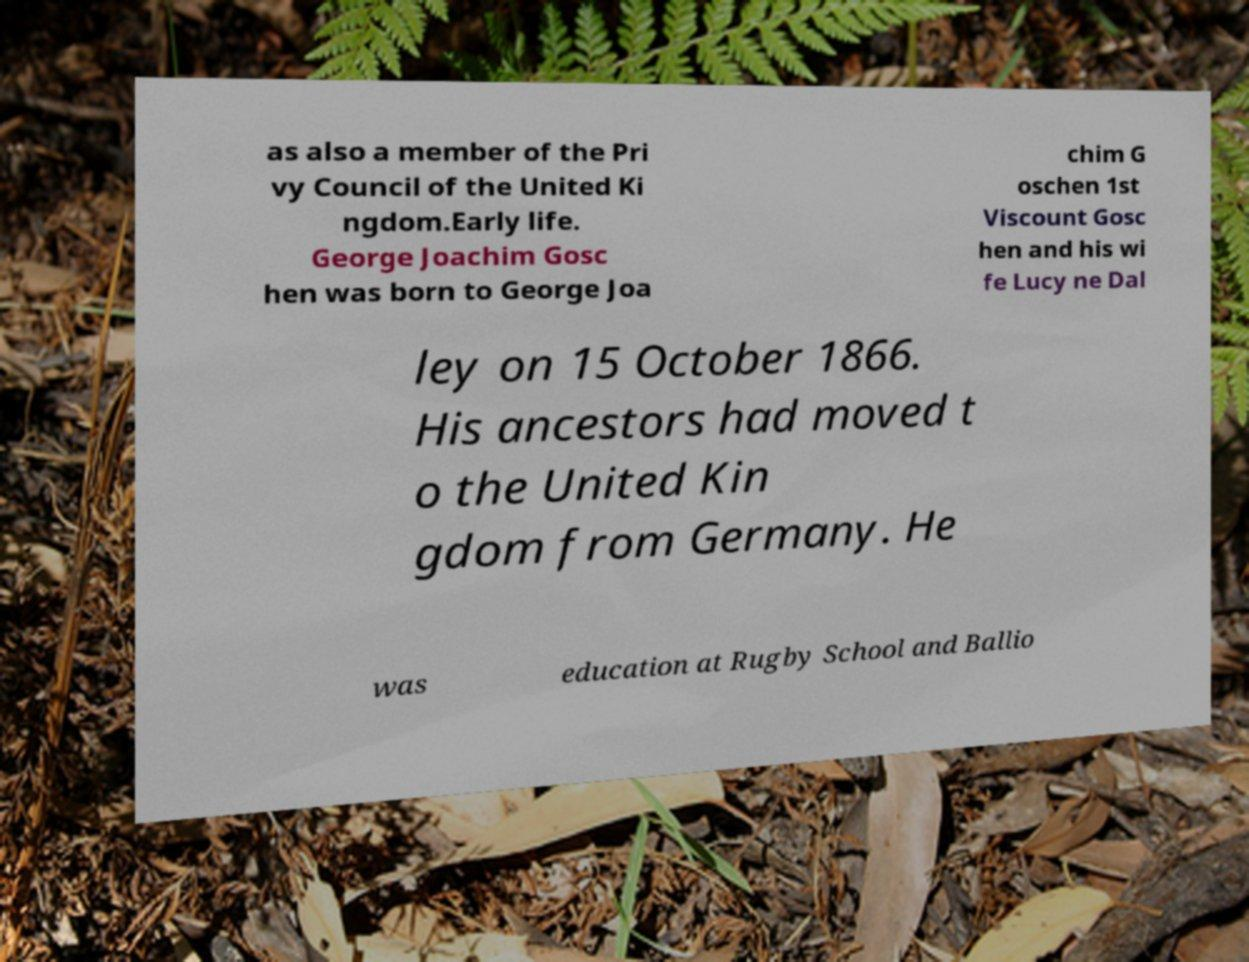I need the written content from this picture converted into text. Can you do that? as also a member of the Pri vy Council of the United Ki ngdom.Early life. George Joachim Gosc hen was born to George Joa chim G oschen 1st Viscount Gosc hen and his wi fe Lucy ne Dal ley on 15 October 1866. His ancestors had moved t o the United Kin gdom from Germany. He was education at Rugby School and Ballio 